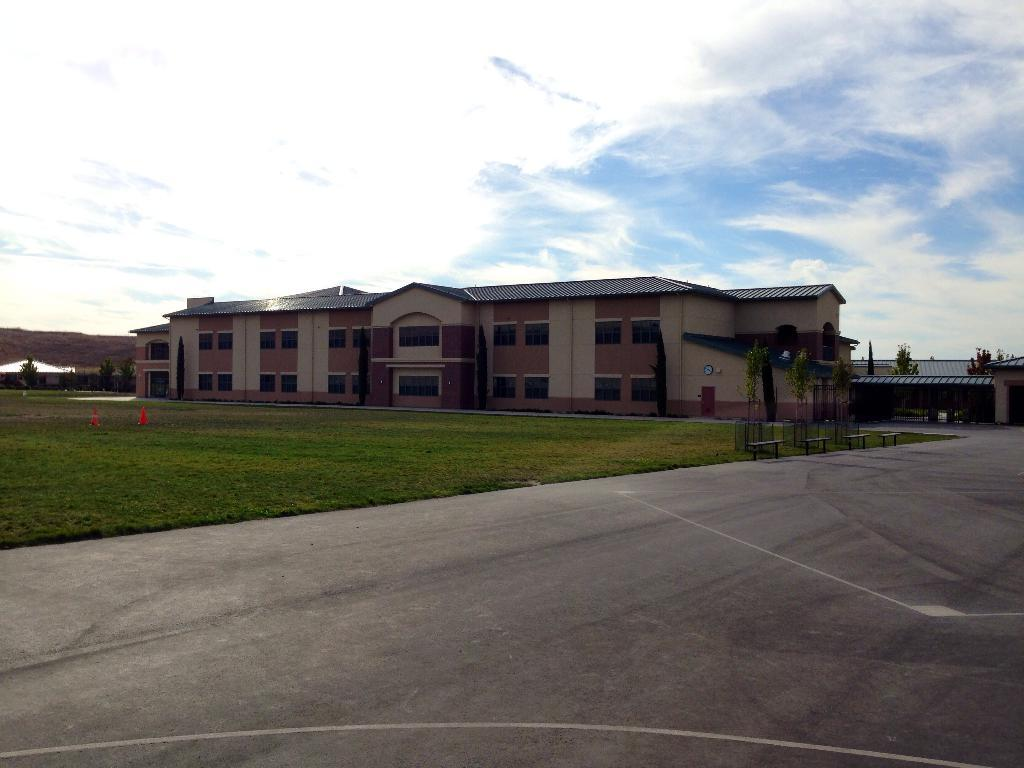What type of structure is visible in the image? There is a building with windows in the image. What type of natural environment is present in the image? There is grass in the image, and plants are also visible. What type of seating can be seen in the image? There are benches in the image. What type of urban infrastructure is present in the image? There are traffic poles in the image. What type of pathway is visible in the image? There is a pathway in the image. What is the condition of the sky in the image? The sky is visible in the image and appears cloudy. Can you see someone kicking a theory in the image? There is no reference to a theory or anyone kicking in the image. What color is the person's toe in the image? There are no people or toes visible in the image. 